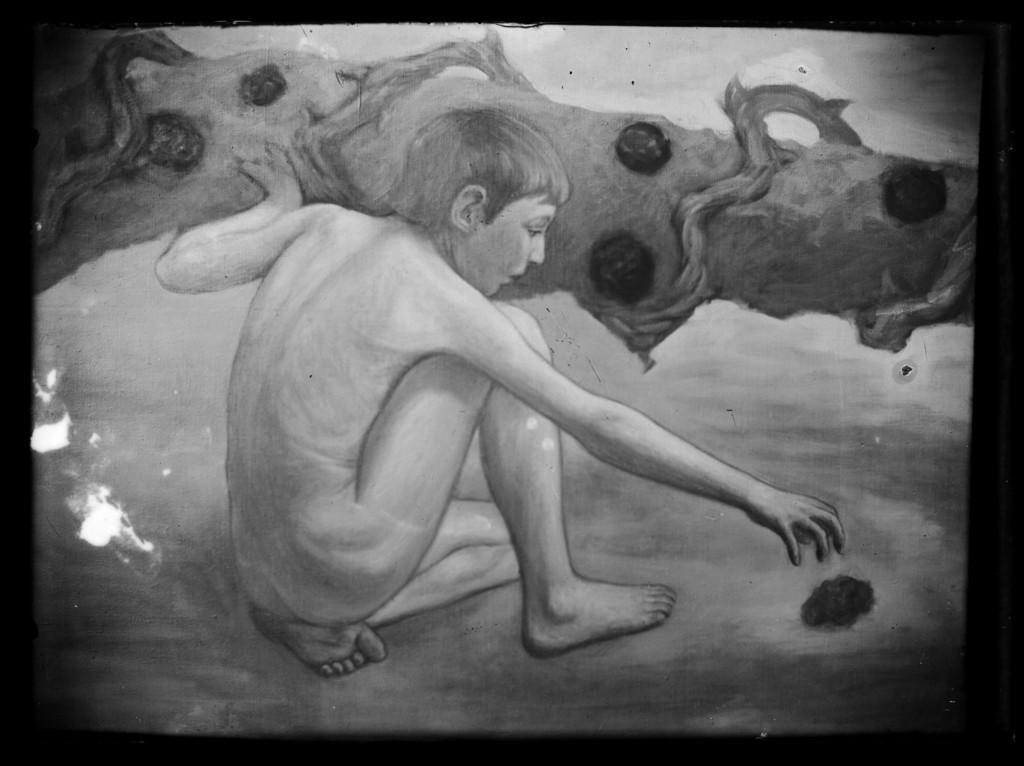Could you give a brief overview of what you see in this image? In this image I can see an art of the person. In the background I can see some object and the image is in black and white. 